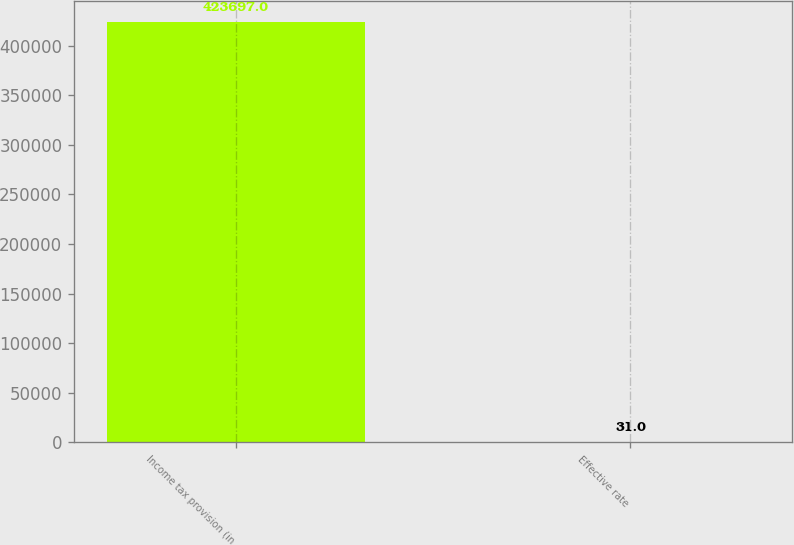<chart> <loc_0><loc_0><loc_500><loc_500><bar_chart><fcel>Income tax provision (in<fcel>Effective rate<nl><fcel>423697<fcel>31<nl></chart> 